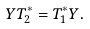Convert formula to latex. <formula><loc_0><loc_0><loc_500><loc_500>Y T _ { 2 } ^ { \ast } = T _ { 1 } ^ { \ast } Y .</formula> 